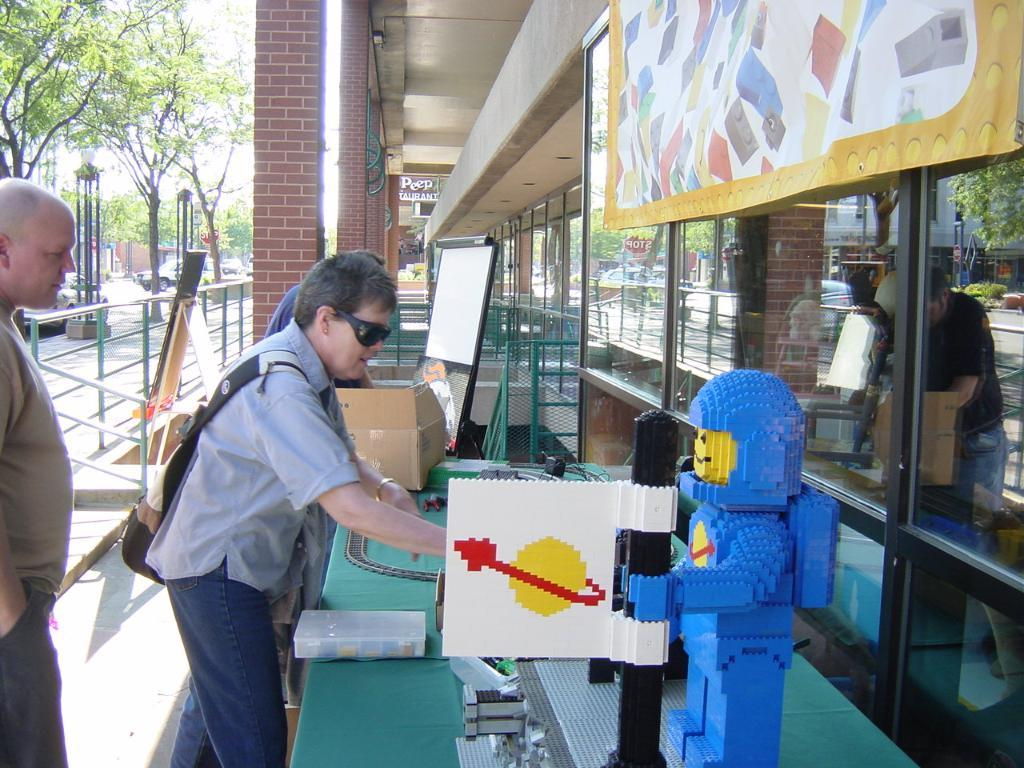What can be seen in the image involving people? There are people standing in the image. What type of toy is present in the image? There is a lego toy in the image. What objects in the image reflect light or images? There are mirrors in the image. What type of natural vegetation is visible in the image? There are trees in the image. What type of vertical structures are present in the image? There are poles in the image. What part of the natural environment is visible in the image? The sky is visible in the image. What type of liquid is being channeled through the people in the image? There is no liquid or channeling present in the image; it features people standing with various objects, including a lego toy, mirrors, trees, poles, and a visible sky. 